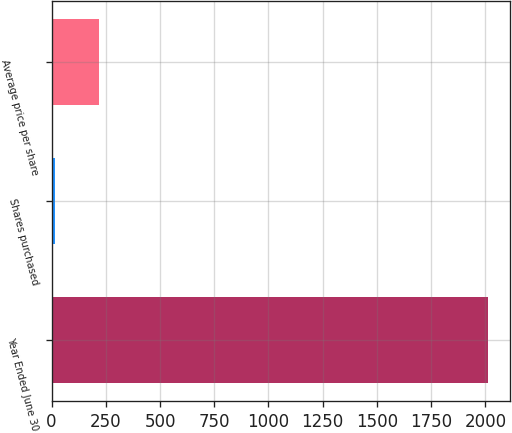<chart> <loc_0><loc_0><loc_500><loc_500><bar_chart><fcel>Year Ended June 30<fcel>Shares purchased<fcel>Average price per share<nl><fcel>2014<fcel>18<fcel>217.6<nl></chart> 